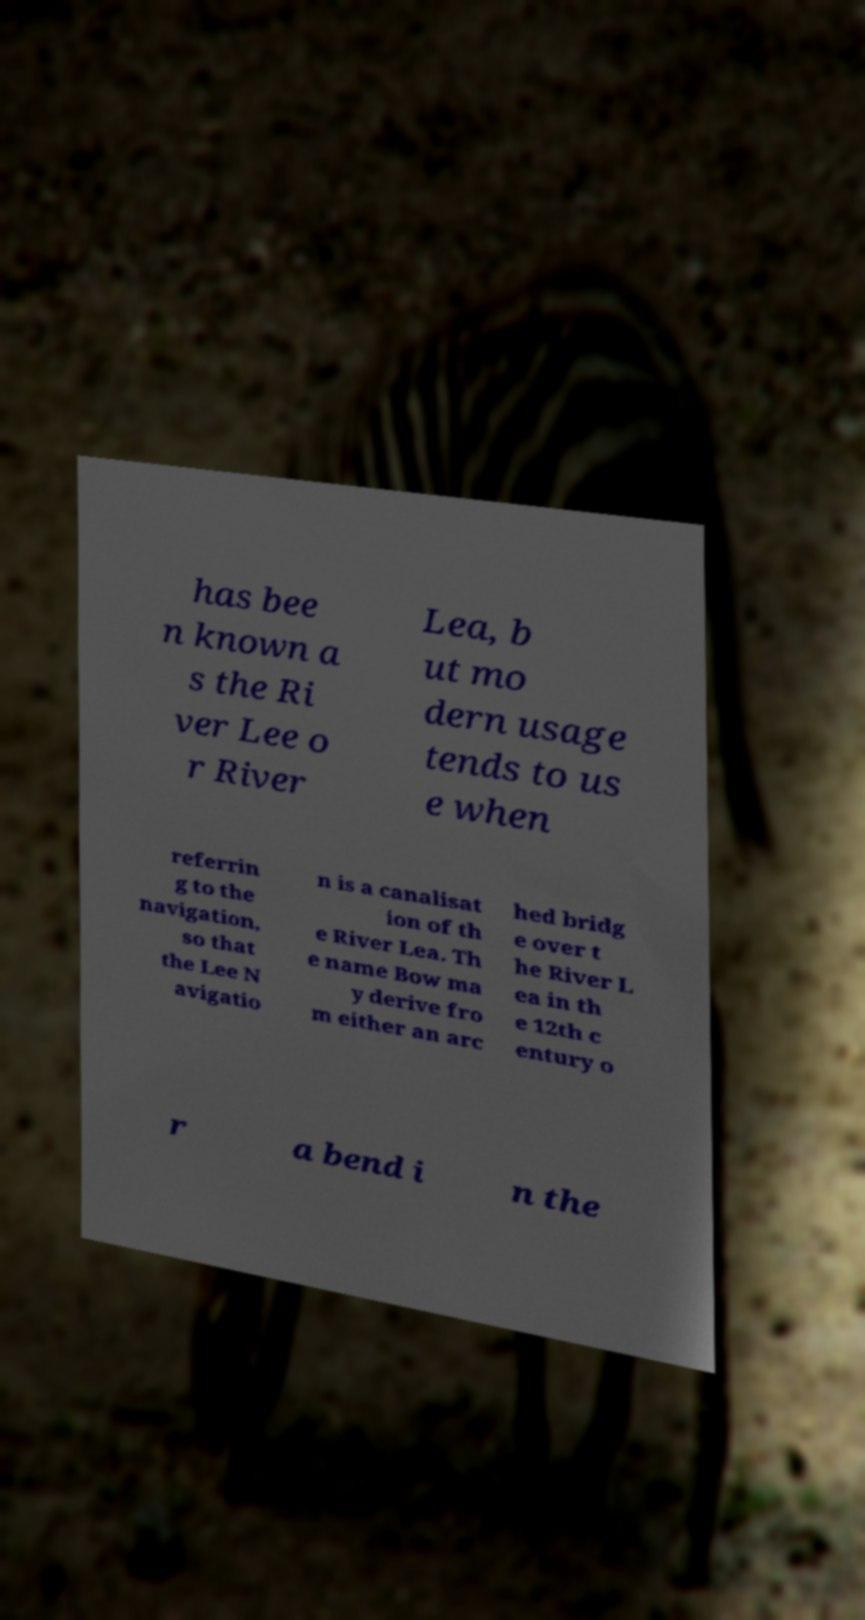Please identify and transcribe the text found in this image. has bee n known a s the Ri ver Lee o r River Lea, b ut mo dern usage tends to us e when referrin g to the navigation, so that the Lee N avigatio n is a canalisat ion of th e River Lea. Th e name Bow ma y derive fro m either an arc hed bridg e over t he River L ea in th e 12th c entury o r a bend i n the 